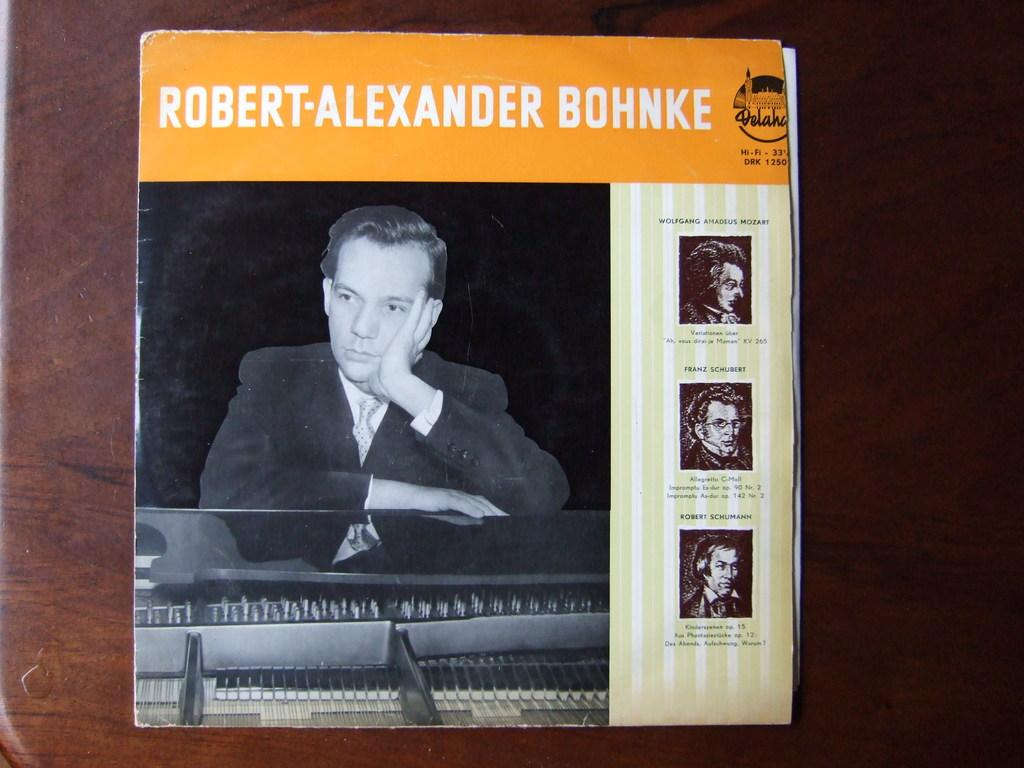What can be seen on the cover page of the book? There are persons on the cover page of the book. What else is present on the cover page besides the persons? There is text written on the cover page. What is the background color of the cover page? The background color of the cover page is brown. Can you tell me how many donkeys are depicted on the cover page? There are no donkeys depicted on the cover page; it features persons and text. What type of cast is shown on the cover page? There is no cast present on the cover page; it only features persons and text. 